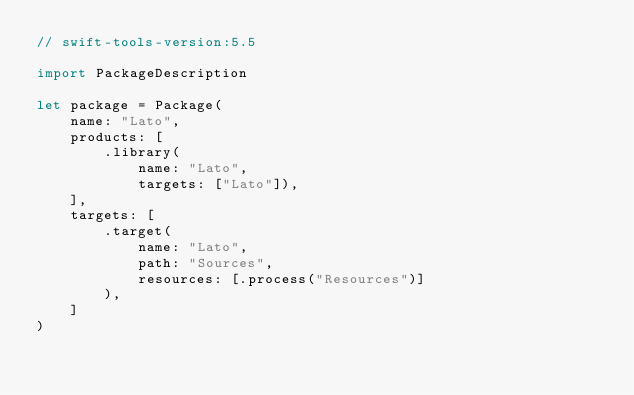<code> <loc_0><loc_0><loc_500><loc_500><_Swift_>// swift-tools-version:5.5

import PackageDescription

let package = Package(
    name: "Lato",
    products: [
        .library(
            name: "Lato",
            targets: ["Lato"]),
    ],
    targets: [
        .target(
            name: "Lato",
            path: "Sources",
            resources: [.process("Resources")]
        ),
    ]
)
</code> 